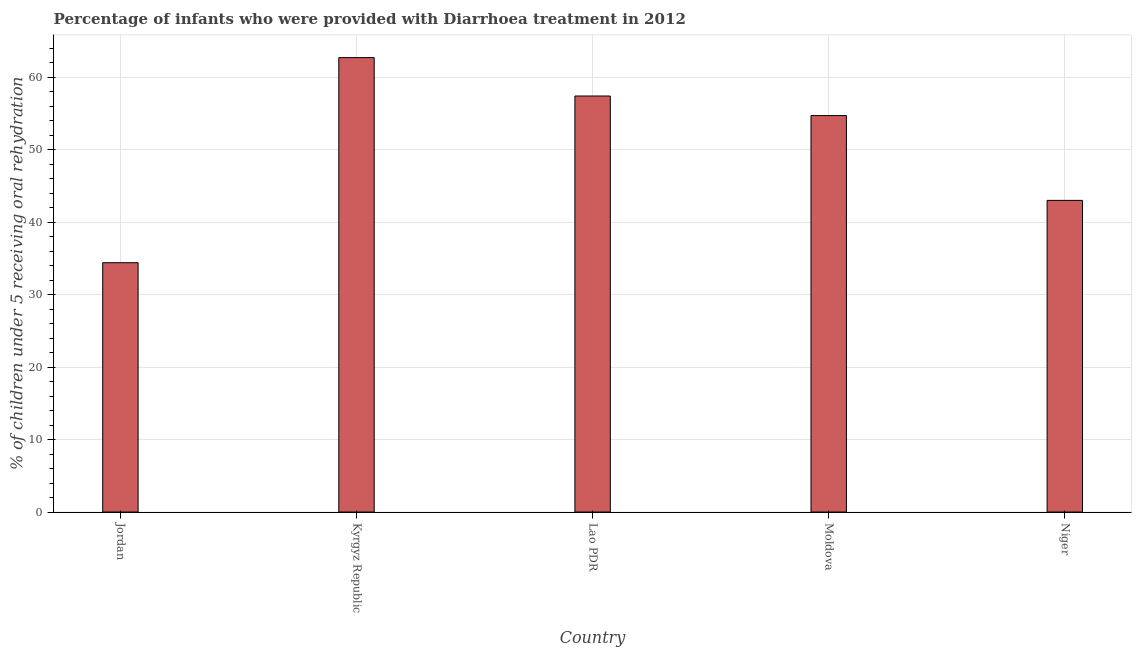Does the graph contain any zero values?
Your answer should be very brief. No. Does the graph contain grids?
Make the answer very short. Yes. What is the title of the graph?
Offer a terse response. Percentage of infants who were provided with Diarrhoea treatment in 2012. What is the label or title of the Y-axis?
Make the answer very short. % of children under 5 receiving oral rehydration. What is the percentage of children who were provided with treatment diarrhoea in Niger?
Your answer should be compact. 43. Across all countries, what is the maximum percentage of children who were provided with treatment diarrhoea?
Ensure brevity in your answer.  62.7. Across all countries, what is the minimum percentage of children who were provided with treatment diarrhoea?
Give a very brief answer. 34.4. In which country was the percentage of children who were provided with treatment diarrhoea maximum?
Keep it short and to the point. Kyrgyz Republic. In which country was the percentage of children who were provided with treatment diarrhoea minimum?
Provide a short and direct response. Jordan. What is the sum of the percentage of children who were provided with treatment diarrhoea?
Offer a terse response. 252.2. What is the difference between the percentage of children who were provided with treatment diarrhoea in Jordan and Moldova?
Keep it short and to the point. -20.3. What is the average percentage of children who were provided with treatment diarrhoea per country?
Provide a short and direct response. 50.44. What is the median percentage of children who were provided with treatment diarrhoea?
Give a very brief answer. 54.7. In how many countries, is the percentage of children who were provided with treatment diarrhoea greater than 56 %?
Provide a short and direct response. 2. What is the ratio of the percentage of children who were provided with treatment diarrhoea in Jordan to that in Niger?
Offer a terse response. 0.8. Is the sum of the percentage of children who were provided with treatment diarrhoea in Kyrgyz Republic and Lao PDR greater than the maximum percentage of children who were provided with treatment diarrhoea across all countries?
Provide a short and direct response. Yes. What is the difference between the highest and the lowest percentage of children who were provided with treatment diarrhoea?
Offer a terse response. 28.3. Are all the bars in the graph horizontal?
Your answer should be very brief. No. How many countries are there in the graph?
Your response must be concise. 5. What is the difference between two consecutive major ticks on the Y-axis?
Give a very brief answer. 10. Are the values on the major ticks of Y-axis written in scientific E-notation?
Keep it short and to the point. No. What is the % of children under 5 receiving oral rehydration of Jordan?
Your response must be concise. 34.4. What is the % of children under 5 receiving oral rehydration of Kyrgyz Republic?
Your answer should be compact. 62.7. What is the % of children under 5 receiving oral rehydration in Lao PDR?
Your response must be concise. 57.4. What is the % of children under 5 receiving oral rehydration of Moldova?
Your response must be concise. 54.7. What is the % of children under 5 receiving oral rehydration in Niger?
Ensure brevity in your answer.  43. What is the difference between the % of children under 5 receiving oral rehydration in Jordan and Kyrgyz Republic?
Your response must be concise. -28.3. What is the difference between the % of children under 5 receiving oral rehydration in Jordan and Lao PDR?
Keep it short and to the point. -23. What is the difference between the % of children under 5 receiving oral rehydration in Jordan and Moldova?
Keep it short and to the point. -20.3. What is the difference between the % of children under 5 receiving oral rehydration in Kyrgyz Republic and Niger?
Keep it short and to the point. 19.7. What is the difference between the % of children under 5 receiving oral rehydration in Lao PDR and Moldova?
Make the answer very short. 2.7. What is the difference between the % of children under 5 receiving oral rehydration in Lao PDR and Niger?
Provide a succinct answer. 14.4. What is the difference between the % of children under 5 receiving oral rehydration in Moldova and Niger?
Give a very brief answer. 11.7. What is the ratio of the % of children under 5 receiving oral rehydration in Jordan to that in Kyrgyz Republic?
Offer a very short reply. 0.55. What is the ratio of the % of children under 5 receiving oral rehydration in Jordan to that in Lao PDR?
Make the answer very short. 0.6. What is the ratio of the % of children under 5 receiving oral rehydration in Jordan to that in Moldova?
Give a very brief answer. 0.63. What is the ratio of the % of children under 5 receiving oral rehydration in Jordan to that in Niger?
Your response must be concise. 0.8. What is the ratio of the % of children under 5 receiving oral rehydration in Kyrgyz Republic to that in Lao PDR?
Ensure brevity in your answer.  1.09. What is the ratio of the % of children under 5 receiving oral rehydration in Kyrgyz Republic to that in Moldova?
Give a very brief answer. 1.15. What is the ratio of the % of children under 5 receiving oral rehydration in Kyrgyz Republic to that in Niger?
Give a very brief answer. 1.46. What is the ratio of the % of children under 5 receiving oral rehydration in Lao PDR to that in Moldova?
Give a very brief answer. 1.05. What is the ratio of the % of children under 5 receiving oral rehydration in Lao PDR to that in Niger?
Provide a succinct answer. 1.33. What is the ratio of the % of children under 5 receiving oral rehydration in Moldova to that in Niger?
Your response must be concise. 1.27. 